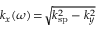<formula> <loc_0><loc_0><loc_500><loc_500>k _ { x } ( \omega ) \, = \, \sqrt { k _ { s p } ^ { 2 } - k _ { y } ^ { 2 } }</formula> 